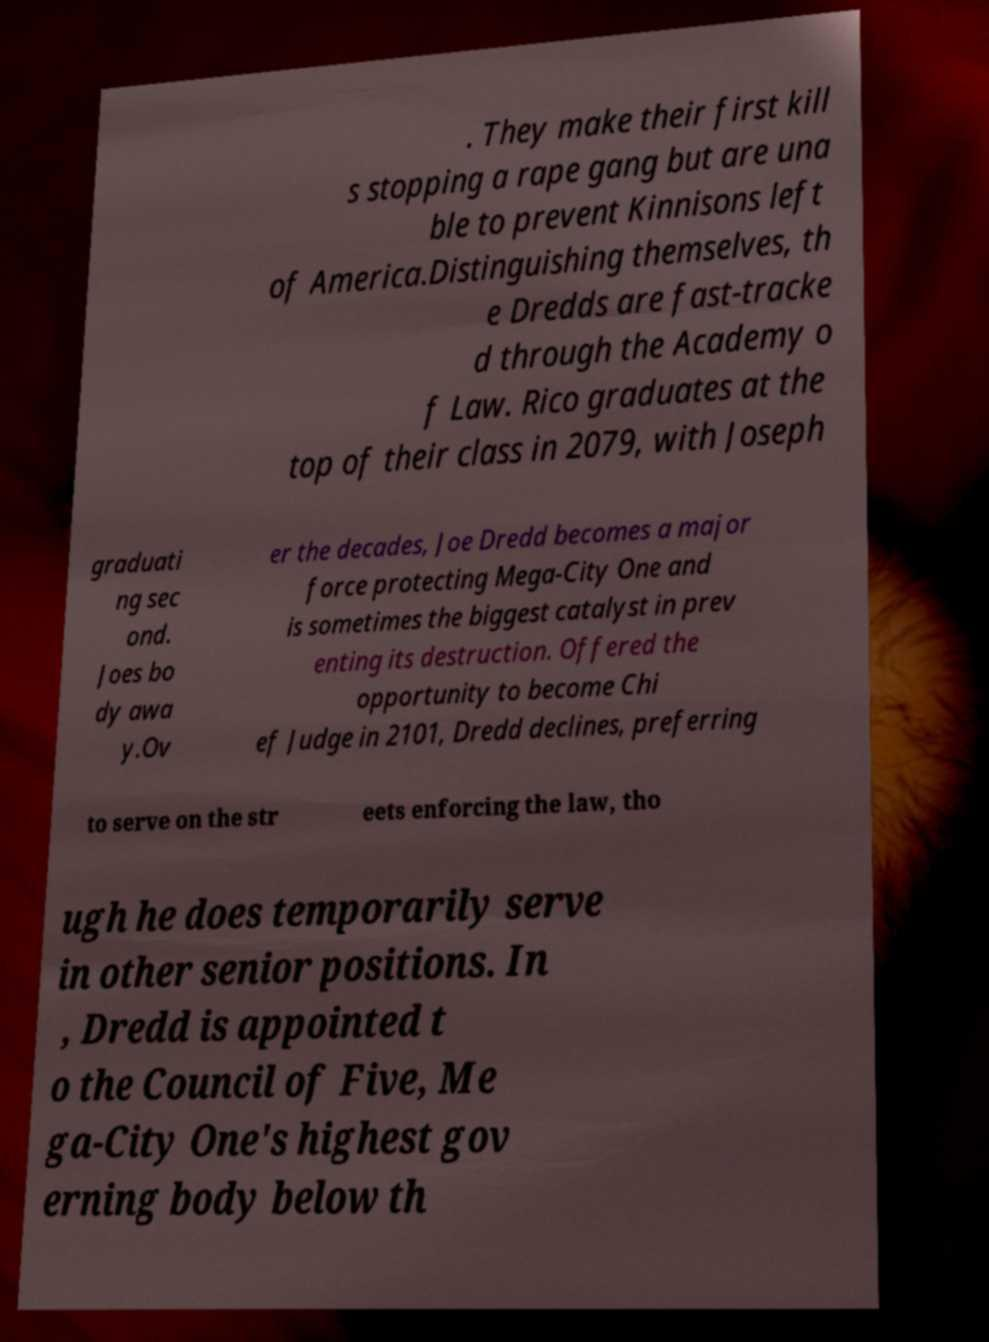Could you extract and type out the text from this image? . They make their first kill s stopping a rape gang but are una ble to prevent Kinnisons left of America.Distinguishing themselves, th e Dredds are fast-tracke d through the Academy o f Law. Rico graduates at the top of their class in 2079, with Joseph graduati ng sec ond. Joes bo dy awa y.Ov er the decades, Joe Dredd becomes a major force protecting Mega-City One and is sometimes the biggest catalyst in prev enting its destruction. Offered the opportunity to become Chi ef Judge in 2101, Dredd declines, preferring to serve on the str eets enforcing the law, tho ugh he does temporarily serve in other senior positions. In , Dredd is appointed t o the Council of Five, Me ga-City One's highest gov erning body below th 